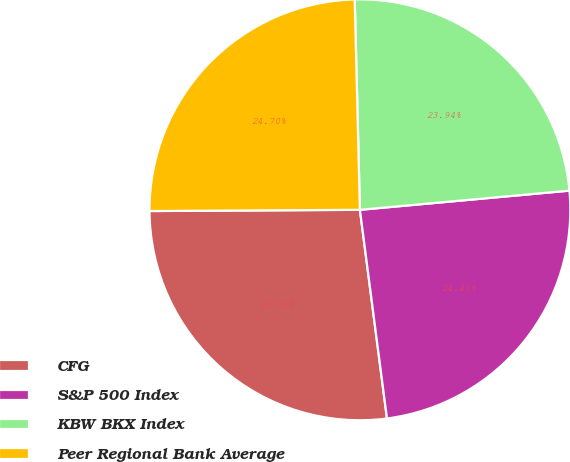Convert chart to OTSL. <chart><loc_0><loc_0><loc_500><loc_500><pie_chart><fcel>CFG<fcel>S&P 500 Index<fcel>KBW BKX Index<fcel>Peer Regional Bank Average<nl><fcel>26.96%<fcel>24.4%<fcel>23.94%<fcel>24.7%<nl></chart> 